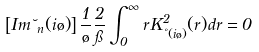Convert formula to latex. <formula><loc_0><loc_0><loc_500><loc_500>\left [ I m \lambda _ { n } ( i \tau ) \right ] \frac { 1 } { \tau } \frac { 2 } { \pi } \int ^ { \infty } _ { 0 } r K ^ { 2 } _ { \nu ( i \tau ) } ( r ) d r = 0</formula> 